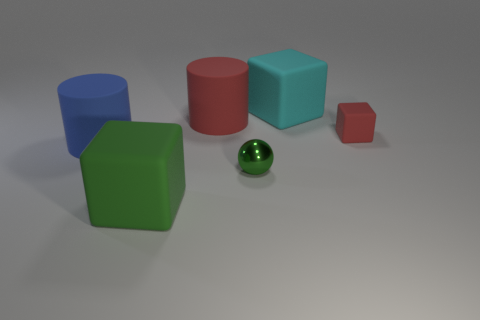Are there any other things that are the same shape as the metal thing?
Make the answer very short. No. Are there any other things that are the same material as the ball?
Offer a terse response. No. Is the size of the red thing behind the red cube the same as the red thing to the right of the red matte cylinder?
Give a very brief answer. No. How many small objects are purple cubes or metallic spheres?
Provide a short and direct response. 1. What number of big matte cubes are both in front of the cyan object and behind the green sphere?
Your response must be concise. 0. Does the cyan thing have the same material as the tiny thing in front of the red cube?
Ensure brevity in your answer.  No. How many green objects are small metallic balls or small blocks?
Make the answer very short. 1. Is there another red cube that has the same size as the red rubber block?
Provide a short and direct response. No. The big block in front of the rubber block behind the matte cube that is right of the big cyan object is made of what material?
Offer a very short reply. Rubber. Are there the same number of small red things that are behind the tiny metal ball and green rubber cubes?
Keep it short and to the point. Yes. 